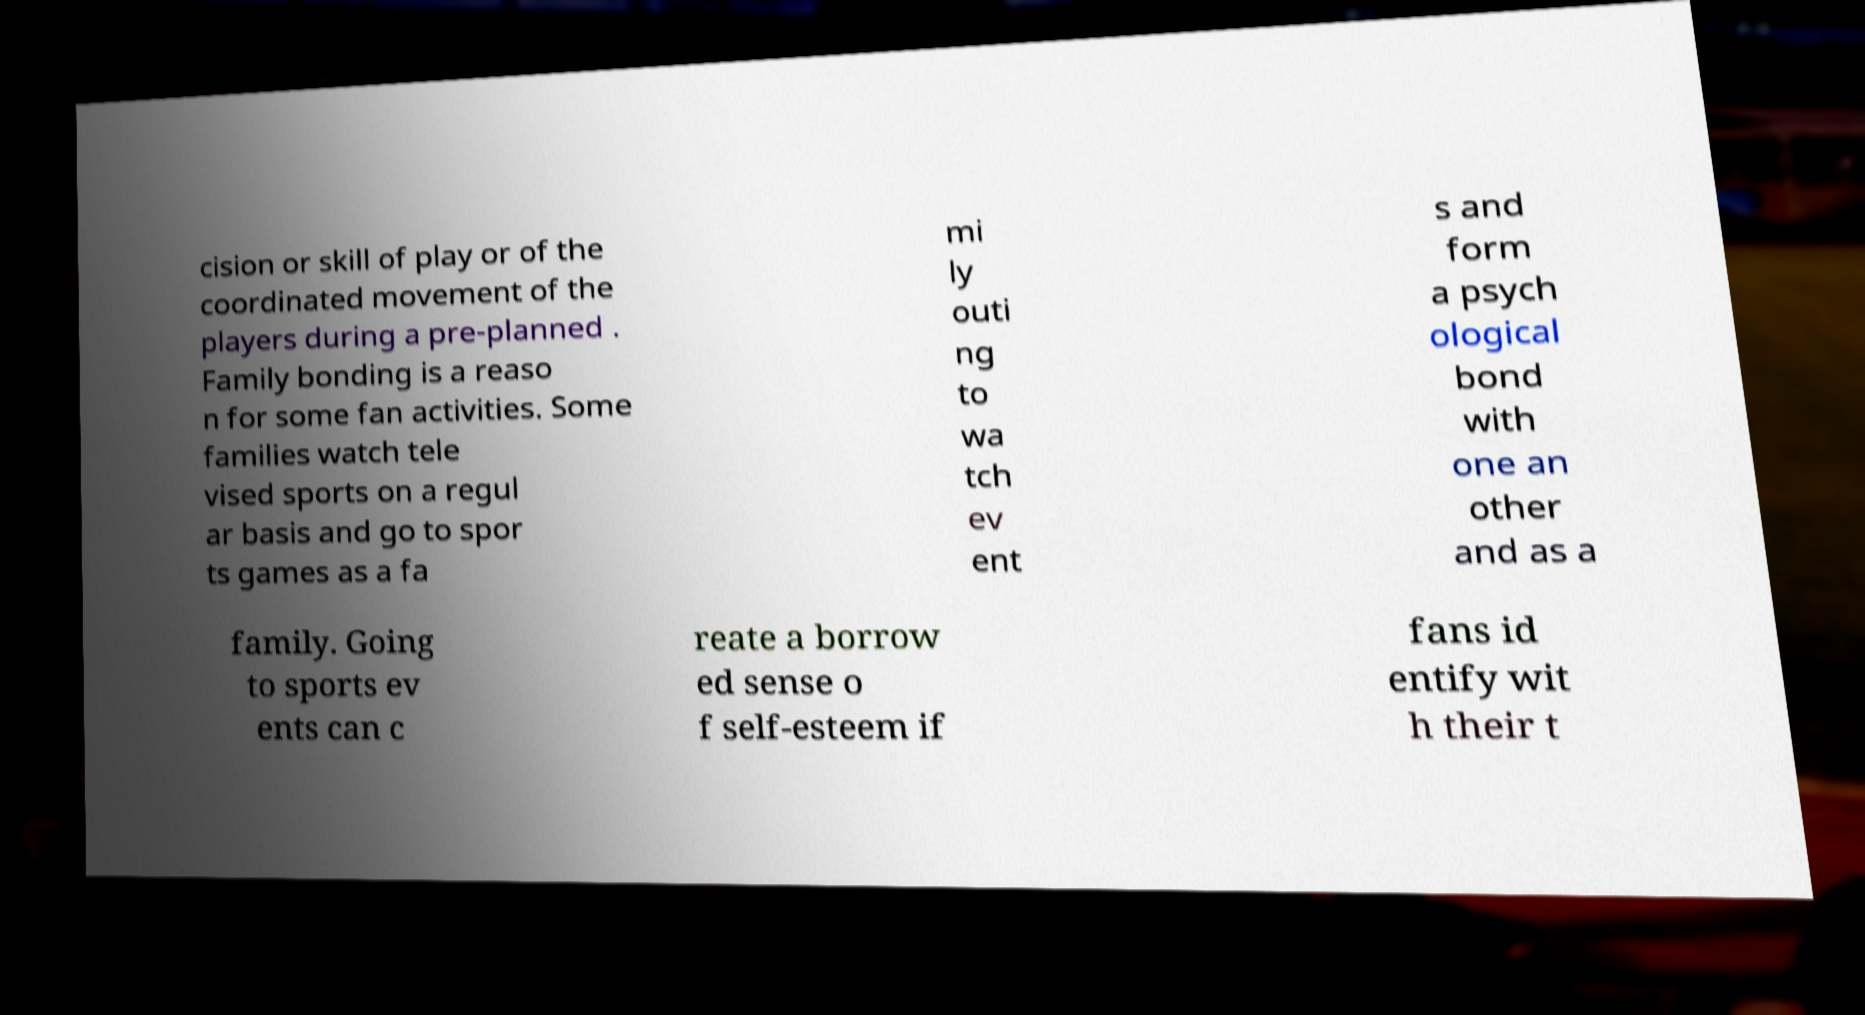Please read and relay the text visible in this image. What does it say? cision or skill of play or of the coordinated movement of the players during a pre-planned . Family bonding is a reaso n for some fan activities. Some families watch tele vised sports on a regul ar basis and go to spor ts games as a fa mi ly outi ng to wa tch ev ent s and form a psych ological bond with one an other and as a family. Going to sports ev ents can c reate a borrow ed sense o f self-esteem if fans id entify wit h their t 